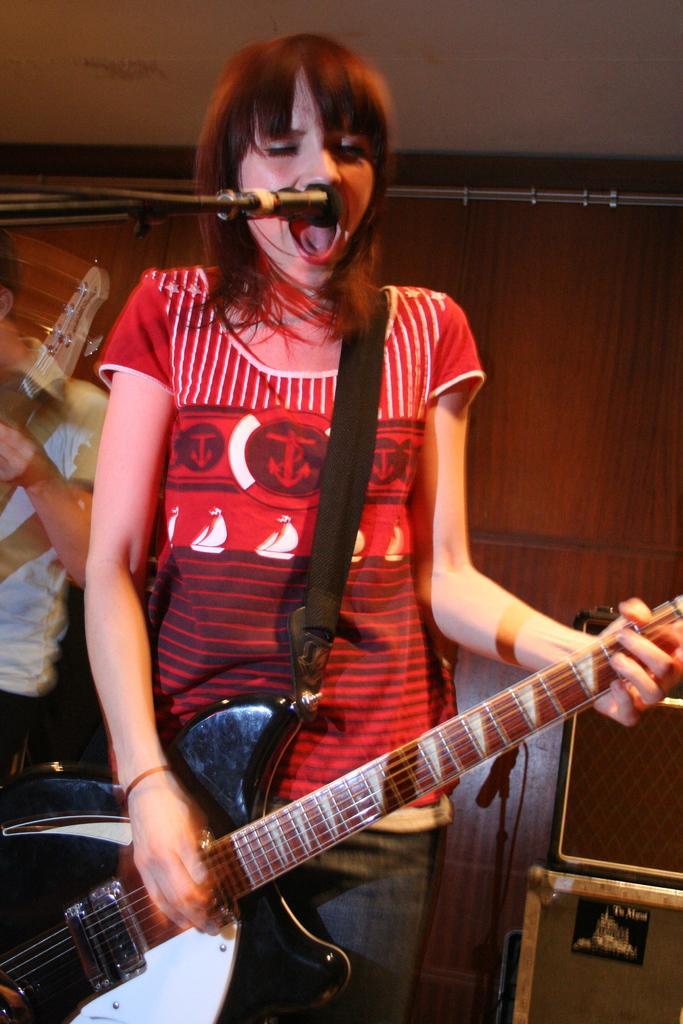How would you summarize this image in a sentence or two? In this image i can see a woman is playing a guitar in front of a microphone. 